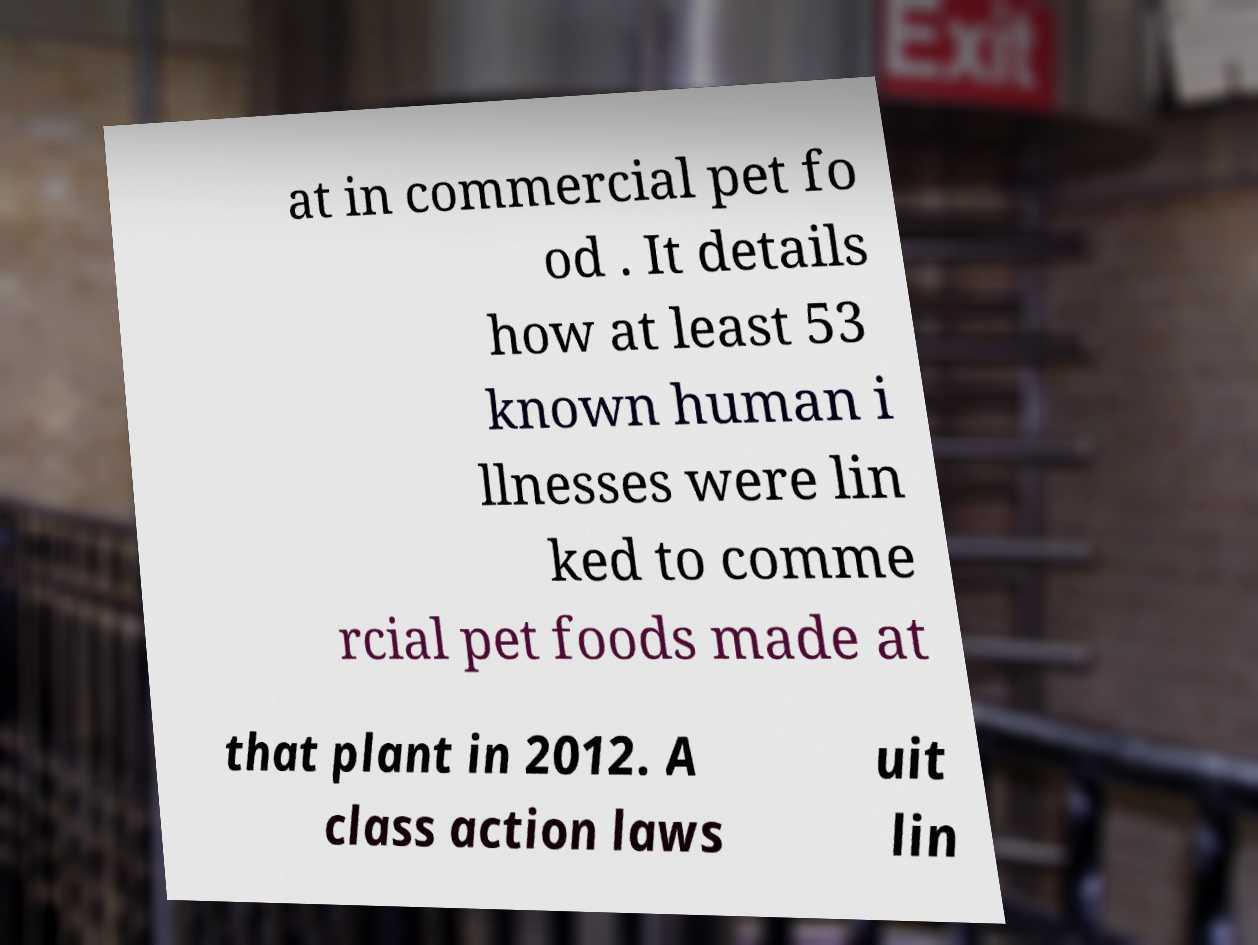There's text embedded in this image that I need extracted. Can you transcribe it verbatim? at in commercial pet fo od . It details how at least 53 known human i llnesses were lin ked to comme rcial pet foods made at that plant in 2012. A class action laws uit lin 